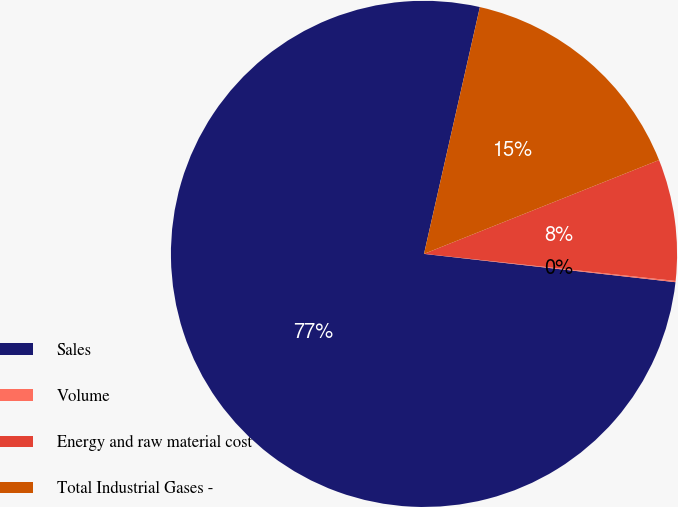<chart> <loc_0><loc_0><loc_500><loc_500><pie_chart><fcel>Sales<fcel>Volume<fcel>Energy and raw material cost<fcel>Total Industrial Gases -<nl><fcel>76.76%<fcel>0.08%<fcel>7.75%<fcel>15.41%<nl></chart> 